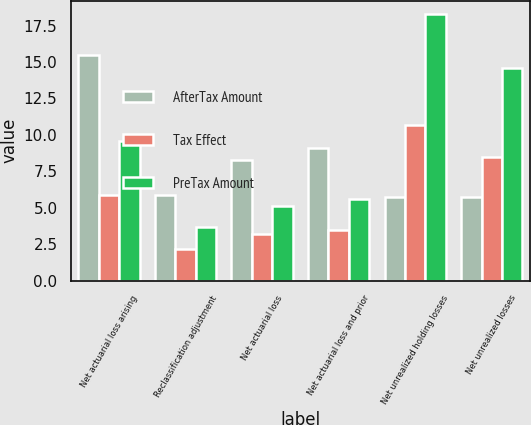Convert chart. <chart><loc_0><loc_0><loc_500><loc_500><stacked_bar_chart><ecel><fcel>Net actuarial loss arising<fcel>Reclassification adjustment<fcel>Net actuarial loss<fcel>Net actuarial loss and prior<fcel>Net unrealized holding losses<fcel>Net unrealized losses<nl><fcel>AfterTax Amount<fcel>15.5<fcel>5.9<fcel>8.3<fcel>9.1<fcel>5.75<fcel>5.75<nl><fcel>Tax Effect<fcel>5.9<fcel>2.2<fcel>3.2<fcel>3.5<fcel>10.7<fcel>8.5<nl><fcel>PreTax Amount<fcel>9.6<fcel>3.7<fcel>5.1<fcel>5.6<fcel>18.3<fcel>14.6<nl></chart> 